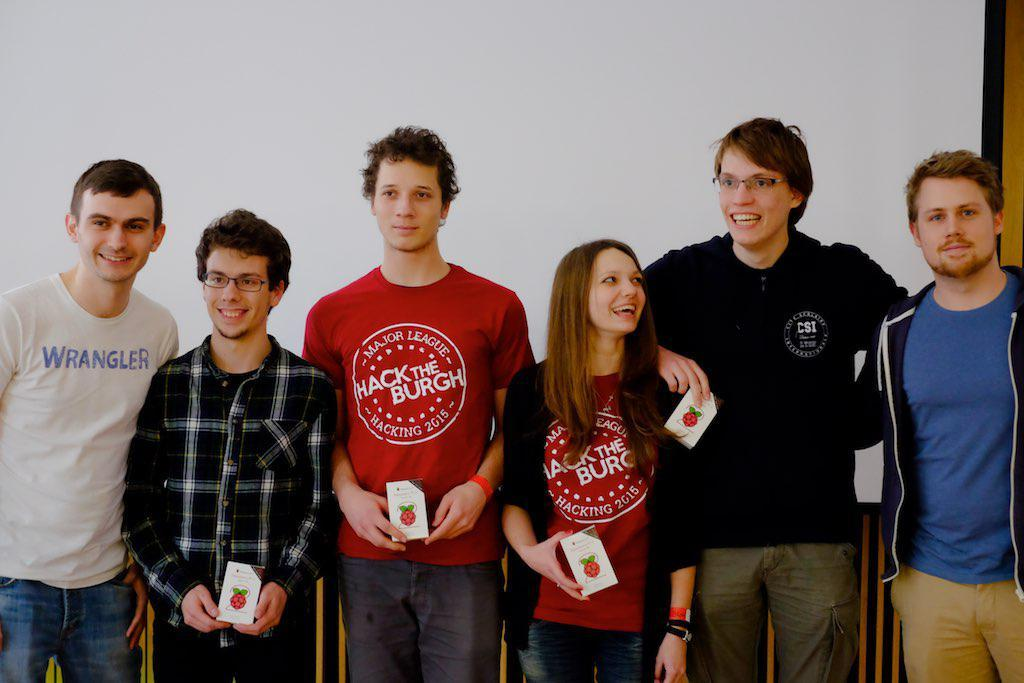<image>
Present a compact description of the photo's key features. Two of the six people in the picture are wearing Hack The Burgh t-shirts. 